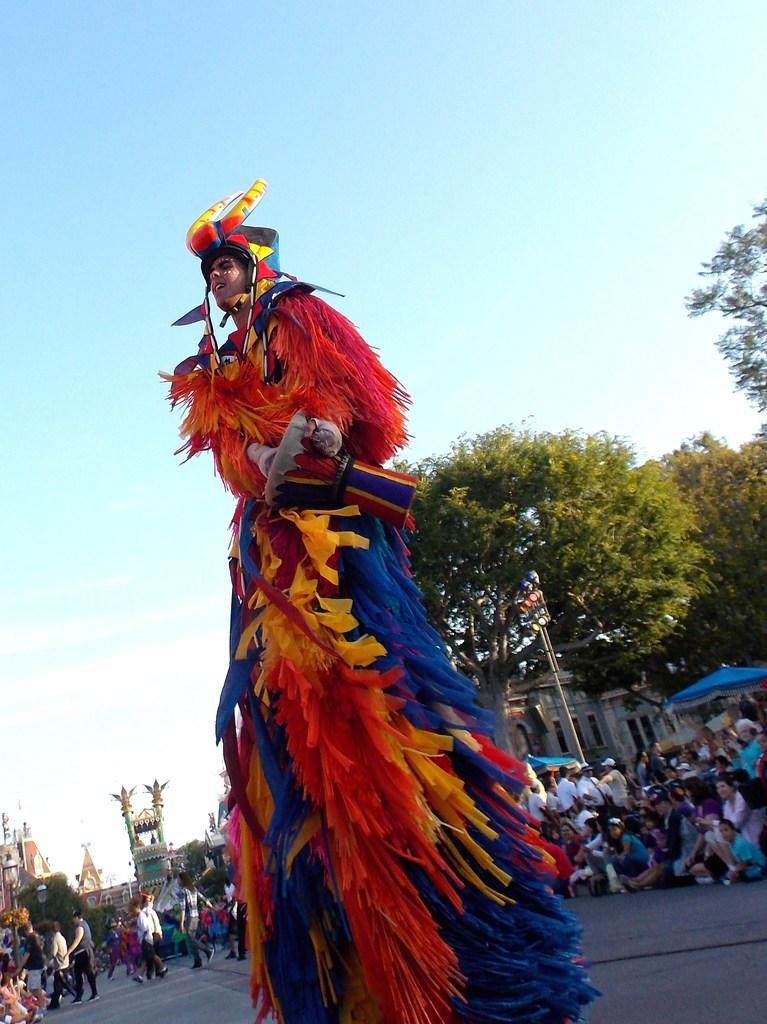Could you give a brief overview of what you see in this image? There is a person wearing a costume. In the background there is a crowd, trees, buildings and sky. 